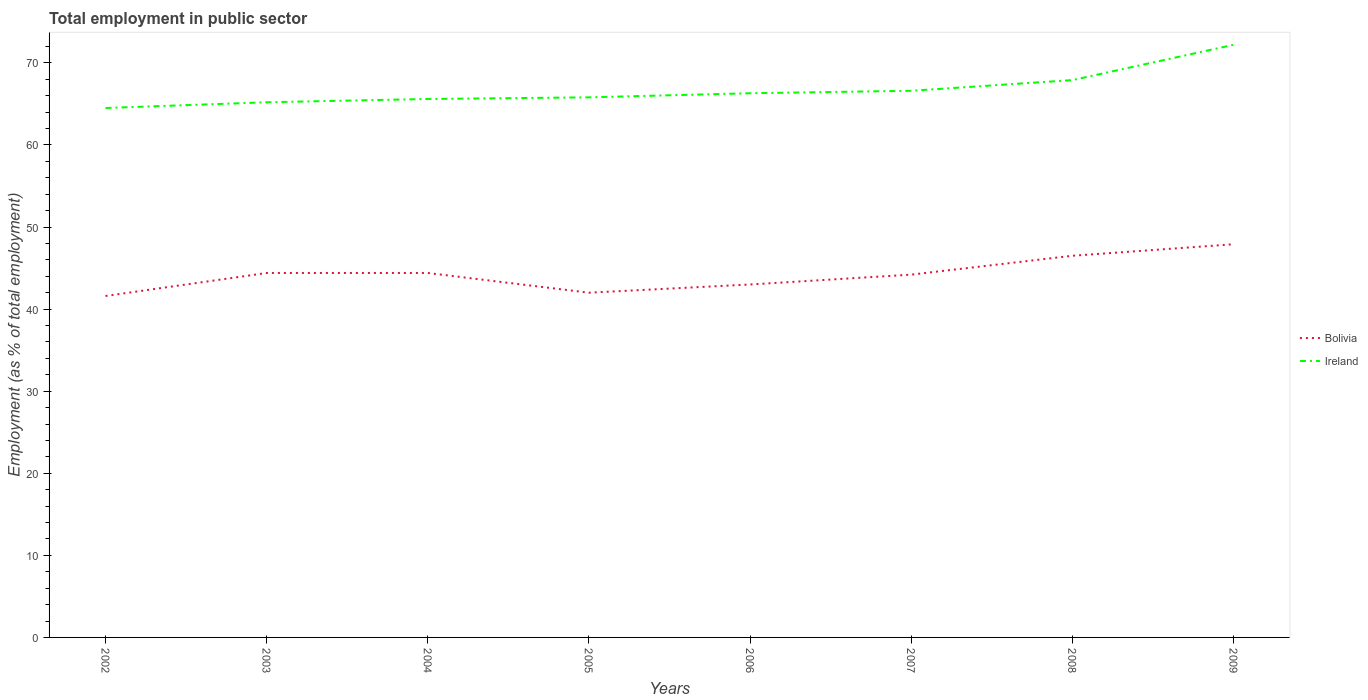Across all years, what is the maximum employment in public sector in Ireland?
Your answer should be very brief. 64.5. What is the total employment in public sector in Bolivia in the graph?
Ensure brevity in your answer.  -4.9. What is the difference between the highest and the second highest employment in public sector in Ireland?
Your response must be concise. 7.7. Is the employment in public sector in Ireland strictly greater than the employment in public sector in Bolivia over the years?
Your answer should be very brief. No. How many lines are there?
Make the answer very short. 2. What is the difference between two consecutive major ticks on the Y-axis?
Ensure brevity in your answer.  10. Does the graph contain grids?
Your response must be concise. No. What is the title of the graph?
Provide a succinct answer. Total employment in public sector. Does "Bolivia" appear as one of the legend labels in the graph?
Offer a terse response. Yes. What is the label or title of the Y-axis?
Make the answer very short. Employment (as % of total employment). What is the Employment (as % of total employment) in Bolivia in 2002?
Your answer should be compact. 41.6. What is the Employment (as % of total employment) of Ireland in 2002?
Your response must be concise. 64.5. What is the Employment (as % of total employment) in Bolivia in 2003?
Provide a succinct answer. 44.4. What is the Employment (as % of total employment) of Ireland in 2003?
Provide a succinct answer. 65.2. What is the Employment (as % of total employment) of Bolivia in 2004?
Give a very brief answer. 44.4. What is the Employment (as % of total employment) of Ireland in 2004?
Ensure brevity in your answer.  65.6. What is the Employment (as % of total employment) of Ireland in 2005?
Offer a very short reply. 65.8. What is the Employment (as % of total employment) in Ireland in 2006?
Your answer should be very brief. 66.3. What is the Employment (as % of total employment) in Bolivia in 2007?
Make the answer very short. 44.2. What is the Employment (as % of total employment) in Ireland in 2007?
Ensure brevity in your answer.  66.6. What is the Employment (as % of total employment) in Bolivia in 2008?
Provide a succinct answer. 46.5. What is the Employment (as % of total employment) in Ireland in 2008?
Provide a short and direct response. 67.9. What is the Employment (as % of total employment) of Bolivia in 2009?
Your answer should be very brief. 47.9. What is the Employment (as % of total employment) in Ireland in 2009?
Your answer should be very brief. 72.2. Across all years, what is the maximum Employment (as % of total employment) in Bolivia?
Offer a terse response. 47.9. Across all years, what is the maximum Employment (as % of total employment) of Ireland?
Your answer should be very brief. 72.2. Across all years, what is the minimum Employment (as % of total employment) of Bolivia?
Your answer should be very brief. 41.6. Across all years, what is the minimum Employment (as % of total employment) in Ireland?
Make the answer very short. 64.5. What is the total Employment (as % of total employment) in Bolivia in the graph?
Your answer should be very brief. 354. What is the total Employment (as % of total employment) of Ireland in the graph?
Keep it short and to the point. 534.1. What is the difference between the Employment (as % of total employment) of Ireland in 2002 and that in 2003?
Keep it short and to the point. -0.7. What is the difference between the Employment (as % of total employment) of Bolivia in 2002 and that in 2004?
Offer a very short reply. -2.8. What is the difference between the Employment (as % of total employment) in Bolivia in 2002 and that in 2006?
Give a very brief answer. -1.4. What is the difference between the Employment (as % of total employment) in Ireland in 2002 and that in 2006?
Your answer should be very brief. -1.8. What is the difference between the Employment (as % of total employment) of Ireland in 2002 and that in 2007?
Keep it short and to the point. -2.1. What is the difference between the Employment (as % of total employment) of Bolivia in 2002 and that in 2009?
Keep it short and to the point. -6.3. What is the difference between the Employment (as % of total employment) of Ireland in 2002 and that in 2009?
Give a very brief answer. -7.7. What is the difference between the Employment (as % of total employment) in Bolivia in 2003 and that in 2004?
Keep it short and to the point. 0. What is the difference between the Employment (as % of total employment) of Ireland in 2003 and that in 2004?
Offer a very short reply. -0.4. What is the difference between the Employment (as % of total employment) of Ireland in 2003 and that in 2005?
Keep it short and to the point. -0.6. What is the difference between the Employment (as % of total employment) in Ireland in 2003 and that in 2006?
Provide a succinct answer. -1.1. What is the difference between the Employment (as % of total employment) in Bolivia in 2003 and that in 2008?
Make the answer very short. -2.1. What is the difference between the Employment (as % of total employment) of Ireland in 2003 and that in 2008?
Keep it short and to the point. -2.7. What is the difference between the Employment (as % of total employment) in Bolivia in 2003 and that in 2009?
Your answer should be compact. -3.5. What is the difference between the Employment (as % of total employment) of Bolivia in 2004 and that in 2005?
Your answer should be very brief. 2.4. What is the difference between the Employment (as % of total employment) in Bolivia in 2004 and that in 2006?
Give a very brief answer. 1.4. What is the difference between the Employment (as % of total employment) of Bolivia in 2004 and that in 2007?
Offer a very short reply. 0.2. What is the difference between the Employment (as % of total employment) of Ireland in 2004 and that in 2008?
Make the answer very short. -2.3. What is the difference between the Employment (as % of total employment) in Bolivia in 2004 and that in 2009?
Your answer should be very brief. -3.5. What is the difference between the Employment (as % of total employment) in Bolivia in 2005 and that in 2006?
Your answer should be compact. -1. What is the difference between the Employment (as % of total employment) of Bolivia in 2005 and that in 2007?
Provide a succinct answer. -2.2. What is the difference between the Employment (as % of total employment) of Ireland in 2005 and that in 2007?
Your response must be concise. -0.8. What is the difference between the Employment (as % of total employment) in Ireland in 2005 and that in 2008?
Your response must be concise. -2.1. What is the difference between the Employment (as % of total employment) in Bolivia in 2005 and that in 2009?
Give a very brief answer. -5.9. What is the difference between the Employment (as % of total employment) in Ireland in 2005 and that in 2009?
Your answer should be very brief. -6.4. What is the difference between the Employment (as % of total employment) in Bolivia in 2006 and that in 2008?
Make the answer very short. -3.5. What is the difference between the Employment (as % of total employment) of Ireland in 2006 and that in 2009?
Provide a succinct answer. -5.9. What is the difference between the Employment (as % of total employment) of Bolivia in 2007 and that in 2008?
Offer a very short reply. -2.3. What is the difference between the Employment (as % of total employment) of Ireland in 2007 and that in 2009?
Offer a terse response. -5.6. What is the difference between the Employment (as % of total employment) in Bolivia in 2008 and that in 2009?
Make the answer very short. -1.4. What is the difference between the Employment (as % of total employment) of Bolivia in 2002 and the Employment (as % of total employment) of Ireland in 2003?
Your response must be concise. -23.6. What is the difference between the Employment (as % of total employment) of Bolivia in 2002 and the Employment (as % of total employment) of Ireland in 2004?
Make the answer very short. -24. What is the difference between the Employment (as % of total employment) in Bolivia in 2002 and the Employment (as % of total employment) in Ireland in 2005?
Your answer should be compact. -24.2. What is the difference between the Employment (as % of total employment) in Bolivia in 2002 and the Employment (as % of total employment) in Ireland in 2006?
Offer a very short reply. -24.7. What is the difference between the Employment (as % of total employment) in Bolivia in 2002 and the Employment (as % of total employment) in Ireland in 2007?
Make the answer very short. -25. What is the difference between the Employment (as % of total employment) in Bolivia in 2002 and the Employment (as % of total employment) in Ireland in 2008?
Give a very brief answer. -26.3. What is the difference between the Employment (as % of total employment) of Bolivia in 2002 and the Employment (as % of total employment) of Ireland in 2009?
Offer a very short reply. -30.6. What is the difference between the Employment (as % of total employment) in Bolivia in 2003 and the Employment (as % of total employment) in Ireland in 2004?
Offer a terse response. -21.2. What is the difference between the Employment (as % of total employment) of Bolivia in 2003 and the Employment (as % of total employment) of Ireland in 2005?
Provide a succinct answer. -21.4. What is the difference between the Employment (as % of total employment) in Bolivia in 2003 and the Employment (as % of total employment) in Ireland in 2006?
Your response must be concise. -21.9. What is the difference between the Employment (as % of total employment) of Bolivia in 2003 and the Employment (as % of total employment) of Ireland in 2007?
Offer a very short reply. -22.2. What is the difference between the Employment (as % of total employment) in Bolivia in 2003 and the Employment (as % of total employment) in Ireland in 2008?
Provide a short and direct response. -23.5. What is the difference between the Employment (as % of total employment) in Bolivia in 2003 and the Employment (as % of total employment) in Ireland in 2009?
Give a very brief answer. -27.8. What is the difference between the Employment (as % of total employment) in Bolivia in 2004 and the Employment (as % of total employment) in Ireland in 2005?
Offer a terse response. -21.4. What is the difference between the Employment (as % of total employment) of Bolivia in 2004 and the Employment (as % of total employment) of Ireland in 2006?
Offer a terse response. -21.9. What is the difference between the Employment (as % of total employment) in Bolivia in 2004 and the Employment (as % of total employment) in Ireland in 2007?
Make the answer very short. -22.2. What is the difference between the Employment (as % of total employment) in Bolivia in 2004 and the Employment (as % of total employment) in Ireland in 2008?
Your answer should be very brief. -23.5. What is the difference between the Employment (as % of total employment) of Bolivia in 2004 and the Employment (as % of total employment) of Ireland in 2009?
Provide a short and direct response. -27.8. What is the difference between the Employment (as % of total employment) of Bolivia in 2005 and the Employment (as % of total employment) of Ireland in 2006?
Give a very brief answer. -24.3. What is the difference between the Employment (as % of total employment) in Bolivia in 2005 and the Employment (as % of total employment) in Ireland in 2007?
Offer a terse response. -24.6. What is the difference between the Employment (as % of total employment) of Bolivia in 2005 and the Employment (as % of total employment) of Ireland in 2008?
Give a very brief answer. -25.9. What is the difference between the Employment (as % of total employment) in Bolivia in 2005 and the Employment (as % of total employment) in Ireland in 2009?
Make the answer very short. -30.2. What is the difference between the Employment (as % of total employment) in Bolivia in 2006 and the Employment (as % of total employment) in Ireland in 2007?
Your response must be concise. -23.6. What is the difference between the Employment (as % of total employment) in Bolivia in 2006 and the Employment (as % of total employment) in Ireland in 2008?
Your response must be concise. -24.9. What is the difference between the Employment (as % of total employment) in Bolivia in 2006 and the Employment (as % of total employment) in Ireland in 2009?
Keep it short and to the point. -29.2. What is the difference between the Employment (as % of total employment) in Bolivia in 2007 and the Employment (as % of total employment) in Ireland in 2008?
Make the answer very short. -23.7. What is the difference between the Employment (as % of total employment) of Bolivia in 2007 and the Employment (as % of total employment) of Ireland in 2009?
Your response must be concise. -28. What is the difference between the Employment (as % of total employment) in Bolivia in 2008 and the Employment (as % of total employment) in Ireland in 2009?
Your answer should be compact. -25.7. What is the average Employment (as % of total employment) of Bolivia per year?
Make the answer very short. 44.25. What is the average Employment (as % of total employment) in Ireland per year?
Ensure brevity in your answer.  66.76. In the year 2002, what is the difference between the Employment (as % of total employment) in Bolivia and Employment (as % of total employment) in Ireland?
Offer a terse response. -22.9. In the year 2003, what is the difference between the Employment (as % of total employment) in Bolivia and Employment (as % of total employment) in Ireland?
Give a very brief answer. -20.8. In the year 2004, what is the difference between the Employment (as % of total employment) of Bolivia and Employment (as % of total employment) of Ireland?
Provide a short and direct response. -21.2. In the year 2005, what is the difference between the Employment (as % of total employment) of Bolivia and Employment (as % of total employment) of Ireland?
Make the answer very short. -23.8. In the year 2006, what is the difference between the Employment (as % of total employment) of Bolivia and Employment (as % of total employment) of Ireland?
Ensure brevity in your answer.  -23.3. In the year 2007, what is the difference between the Employment (as % of total employment) of Bolivia and Employment (as % of total employment) of Ireland?
Your answer should be compact. -22.4. In the year 2008, what is the difference between the Employment (as % of total employment) in Bolivia and Employment (as % of total employment) in Ireland?
Give a very brief answer. -21.4. In the year 2009, what is the difference between the Employment (as % of total employment) of Bolivia and Employment (as % of total employment) of Ireland?
Provide a succinct answer. -24.3. What is the ratio of the Employment (as % of total employment) in Bolivia in 2002 to that in 2003?
Your answer should be very brief. 0.94. What is the ratio of the Employment (as % of total employment) of Ireland in 2002 to that in 2003?
Ensure brevity in your answer.  0.99. What is the ratio of the Employment (as % of total employment) of Bolivia in 2002 to that in 2004?
Your answer should be compact. 0.94. What is the ratio of the Employment (as % of total employment) in Ireland in 2002 to that in 2004?
Provide a short and direct response. 0.98. What is the ratio of the Employment (as % of total employment) of Ireland in 2002 to that in 2005?
Make the answer very short. 0.98. What is the ratio of the Employment (as % of total employment) of Bolivia in 2002 to that in 2006?
Provide a succinct answer. 0.97. What is the ratio of the Employment (as % of total employment) of Ireland in 2002 to that in 2006?
Offer a very short reply. 0.97. What is the ratio of the Employment (as % of total employment) of Bolivia in 2002 to that in 2007?
Your response must be concise. 0.94. What is the ratio of the Employment (as % of total employment) in Ireland in 2002 to that in 2007?
Ensure brevity in your answer.  0.97. What is the ratio of the Employment (as % of total employment) in Bolivia in 2002 to that in 2008?
Your answer should be compact. 0.89. What is the ratio of the Employment (as % of total employment) of Ireland in 2002 to that in 2008?
Provide a short and direct response. 0.95. What is the ratio of the Employment (as % of total employment) of Bolivia in 2002 to that in 2009?
Keep it short and to the point. 0.87. What is the ratio of the Employment (as % of total employment) of Ireland in 2002 to that in 2009?
Ensure brevity in your answer.  0.89. What is the ratio of the Employment (as % of total employment) in Bolivia in 2003 to that in 2005?
Provide a succinct answer. 1.06. What is the ratio of the Employment (as % of total employment) in Ireland in 2003 to that in 2005?
Give a very brief answer. 0.99. What is the ratio of the Employment (as % of total employment) in Bolivia in 2003 to that in 2006?
Provide a short and direct response. 1.03. What is the ratio of the Employment (as % of total employment) of Ireland in 2003 to that in 2006?
Your answer should be compact. 0.98. What is the ratio of the Employment (as % of total employment) of Bolivia in 2003 to that in 2008?
Offer a very short reply. 0.95. What is the ratio of the Employment (as % of total employment) of Ireland in 2003 to that in 2008?
Provide a short and direct response. 0.96. What is the ratio of the Employment (as % of total employment) of Bolivia in 2003 to that in 2009?
Give a very brief answer. 0.93. What is the ratio of the Employment (as % of total employment) in Ireland in 2003 to that in 2009?
Your answer should be very brief. 0.9. What is the ratio of the Employment (as % of total employment) of Bolivia in 2004 to that in 2005?
Keep it short and to the point. 1.06. What is the ratio of the Employment (as % of total employment) in Bolivia in 2004 to that in 2006?
Keep it short and to the point. 1.03. What is the ratio of the Employment (as % of total employment) in Bolivia in 2004 to that in 2007?
Make the answer very short. 1. What is the ratio of the Employment (as % of total employment) of Ireland in 2004 to that in 2007?
Keep it short and to the point. 0.98. What is the ratio of the Employment (as % of total employment) in Bolivia in 2004 to that in 2008?
Your response must be concise. 0.95. What is the ratio of the Employment (as % of total employment) in Ireland in 2004 to that in 2008?
Your answer should be very brief. 0.97. What is the ratio of the Employment (as % of total employment) in Bolivia in 2004 to that in 2009?
Offer a terse response. 0.93. What is the ratio of the Employment (as % of total employment) in Ireland in 2004 to that in 2009?
Your response must be concise. 0.91. What is the ratio of the Employment (as % of total employment) in Bolivia in 2005 to that in 2006?
Ensure brevity in your answer.  0.98. What is the ratio of the Employment (as % of total employment) in Bolivia in 2005 to that in 2007?
Your response must be concise. 0.95. What is the ratio of the Employment (as % of total employment) of Bolivia in 2005 to that in 2008?
Provide a short and direct response. 0.9. What is the ratio of the Employment (as % of total employment) of Ireland in 2005 to that in 2008?
Your response must be concise. 0.97. What is the ratio of the Employment (as % of total employment) of Bolivia in 2005 to that in 2009?
Make the answer very short. 0.88. What is the ratio of the Employment (as % of total employment) of Ireland in 2005 to that in 2009?
Provide a short and direct response. 0.91. What is the ratio of the Employment (as % of total employment) of Bolivia in 2006 to that in 2007?
Your response must be concise. 0.97. What is the ratio of the Employment (as % of total employment) of Ireland in 2006 to that in 2007?
Your answer should be very brief. 1. What is the ratio of the Employment (as % of total employment) in Bolivia in 2006 to that in 2008?
Keep it short and to the point. 0.92. What is the ratio of the Employment (as % of total employment) in Ireland in 2006 to that in 2008?
Your answer should be very brief. 0.98. What is the ratio of the Employment (as % of total employment) of Bolivia in 2006 to that in 2009?
Your answer should be very brief. 0.9. What is the ratio of the Employment (as % of total employment) in Ireland in 2006 to that in 2009?
Offer a terse response. 0.92. What is the ratio of the Employment (as % of total employment) of Bolivia in 2007 to that in 2008?
Keep it short and to the point. 0.95. What is the ratio of the Employment (as % of total employment) in Ireland in 2007 to that in 2008?
Provide a succinct answer. 0.98. What is the ratio of the Employment (as % of total employment) in Bolivia in 2007 to that in 2009?
Keep it short and to the point. 0.92. What is the ratio of the Employment (as % of total employment) of Ireland in 2007 to that in 2009?
Provide a short and direct response. 0.92. What is the ratio of the Employment (as % of total employment) of Bolivia in 2008 to that in 2009?
Ensure brevity in your answer.  0.97. What is the ratio of the Employment (as % of total employment) in Ireland in 2008 to that in 2009?
Your answer should be very brief. 0.94. What is the difference between the highest and the second highest Employment (as % of total employment) in Ireland?
Ensure brevity in your answer.  4.3. What is the difference between the highest and the lowest Employment (as % of total employment) of Ireland?
Offer a very short reply. 7.7. 